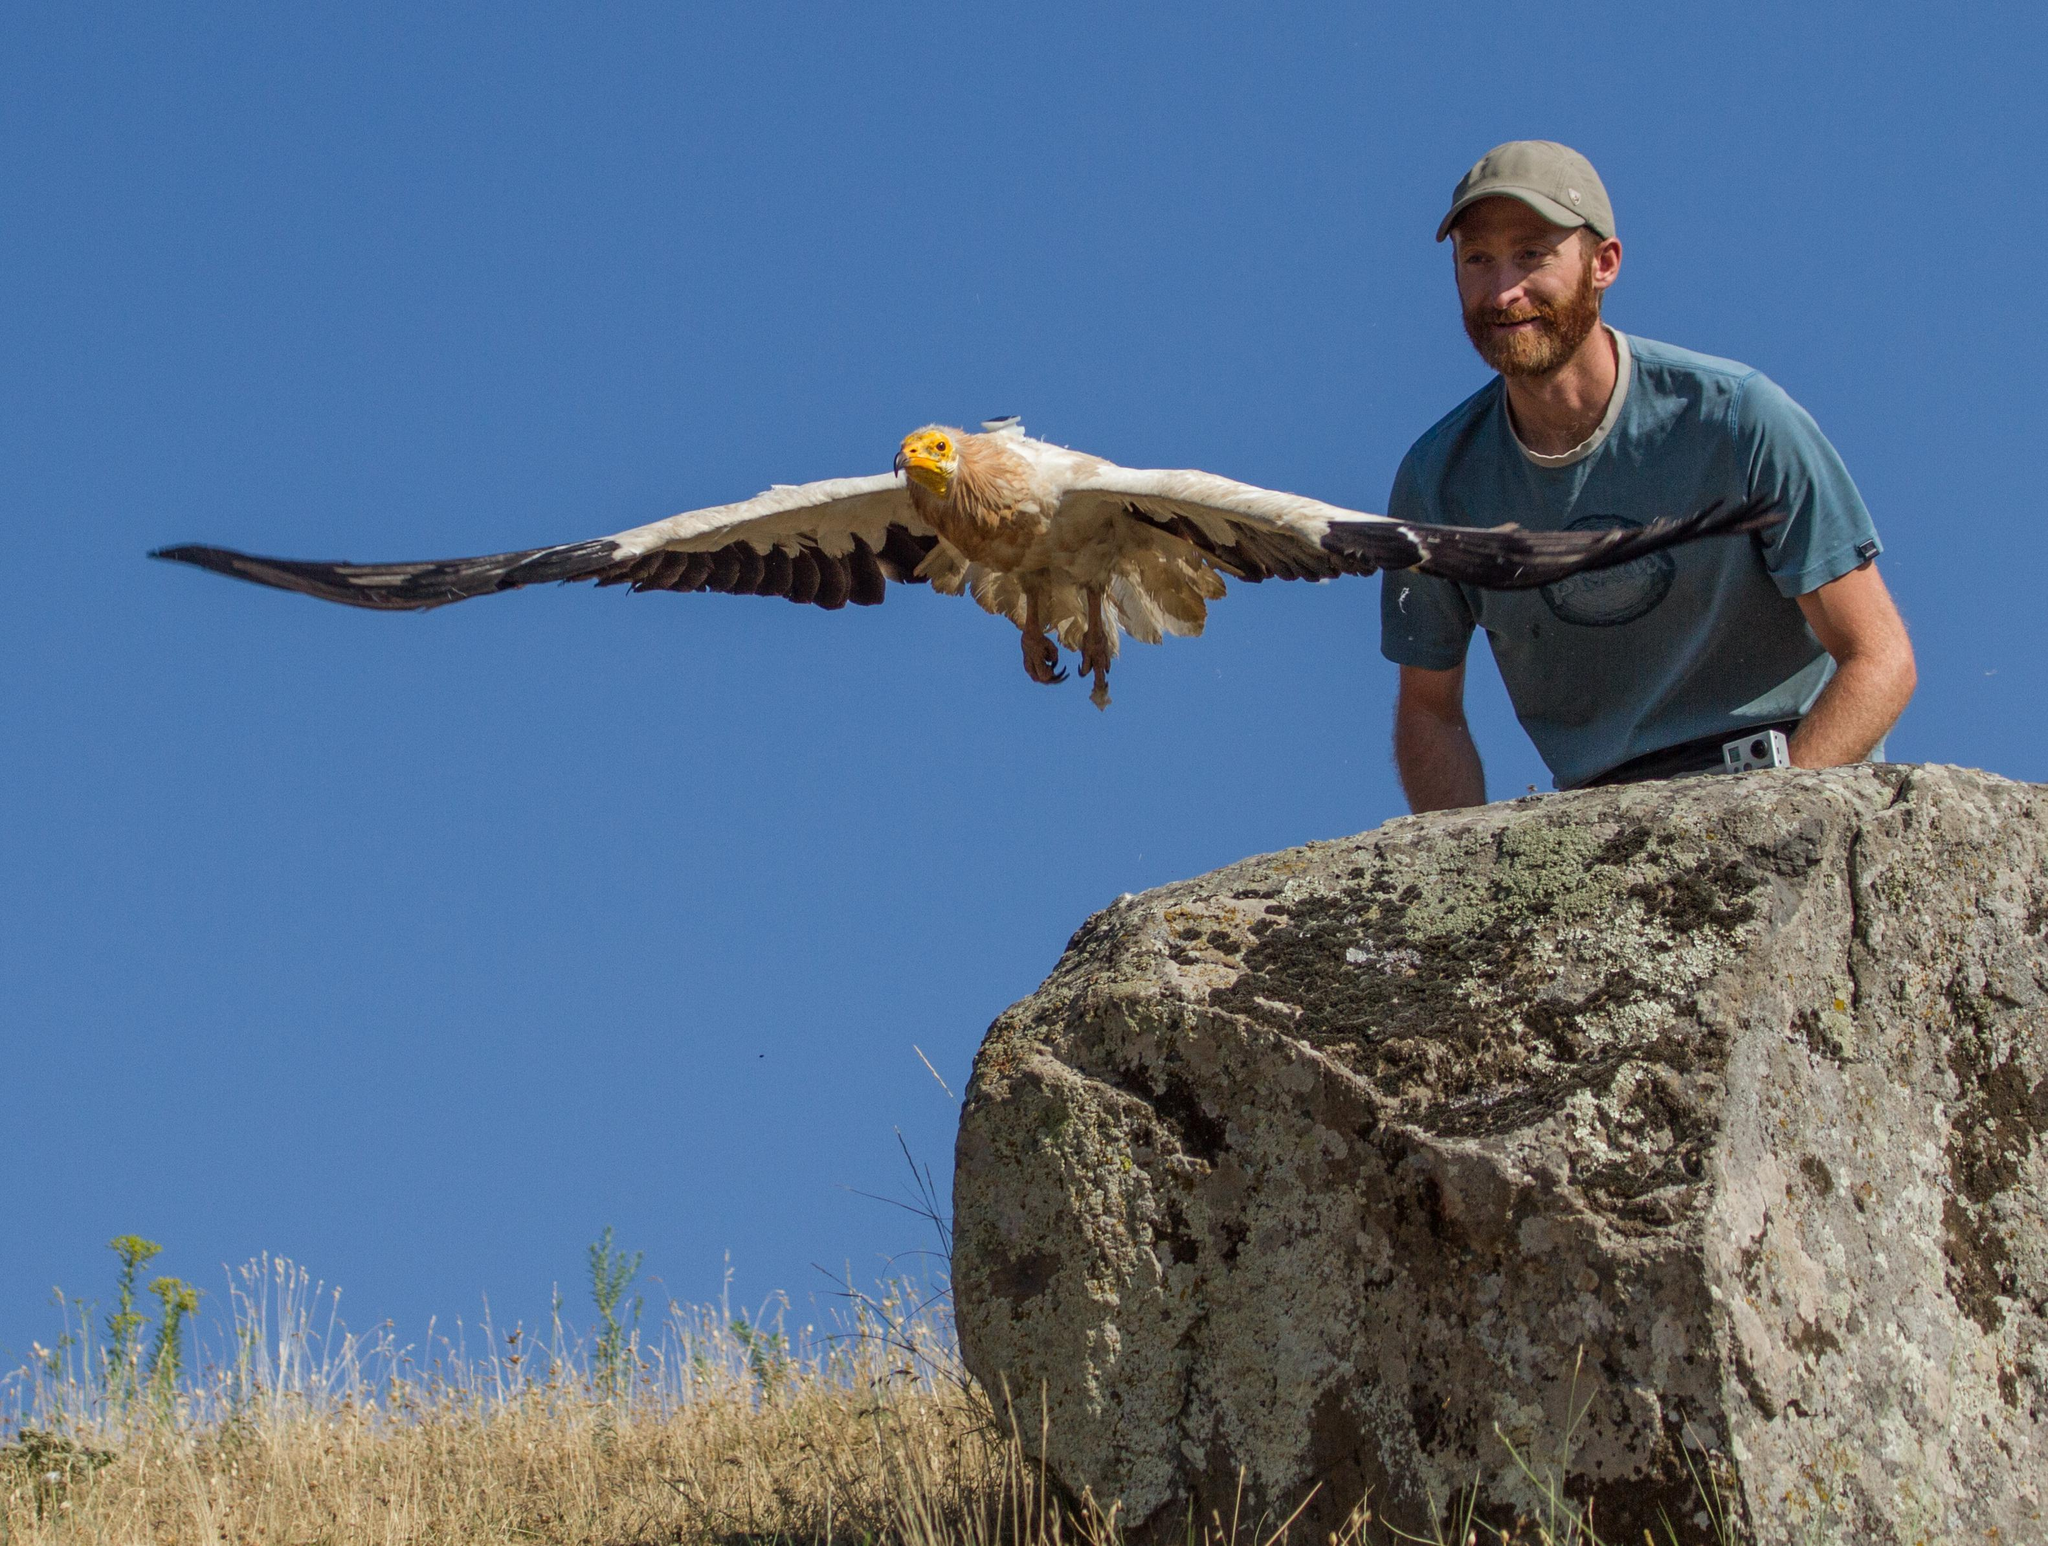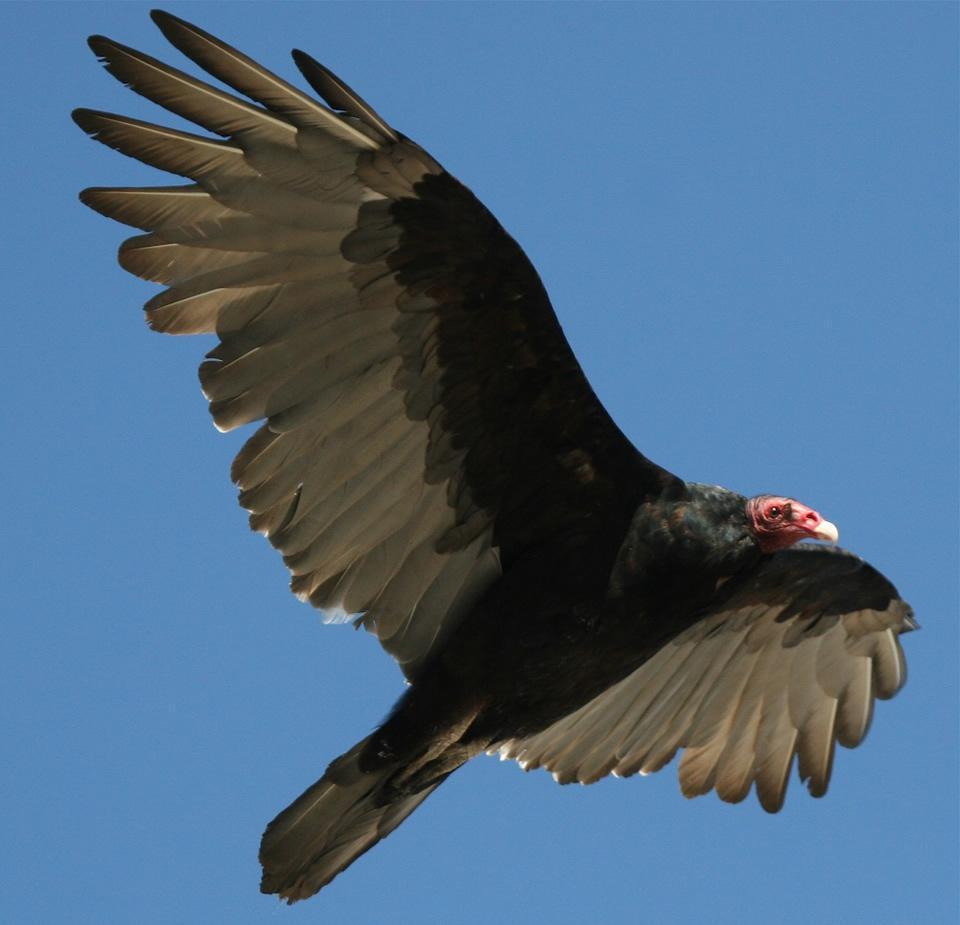The first image is the image on the left, the second image is the image on the right. For the images displayed, is the sentence "The bird on the left is flying in the air." factually correct? Answer yes or no. Yes. The first image is the image on the left, the second image is the image on the right. Considering the images on both sides, is "There is at least one vulture with a gray head and black feathers perched upon a piece of wood." valid? Answer yes or no. No. 